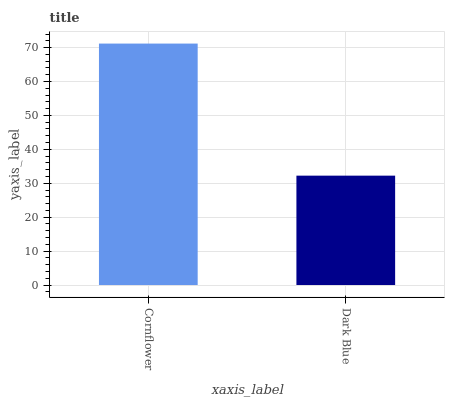Is Dark Blue the minimum?
Answer yes or no. Yes. Is Cornflower the maximum?
Answer yes or no. Yes. Is Dark Blue the maximum?
Answer yes or no. No. Is Cornflower greater than Dark Blue?
Answer yes or no. Yes. Is Dark Blue less than Cornflower?
Answer yes or no. Yes. Is Dark Blue greater than Cornflower?
Answer yes or no. No. Is Cornflower less than Dark Blue?
Answer yes or no. No. Is Cornflower the high median?
Answer yes or no. Yes. Is Dark Blue the low median?
Answer yes or no. Yes. Is Dark Blue the high median?
Answer yes or no. No. Is Cornflower the low median?
Answer yes or no. No. 